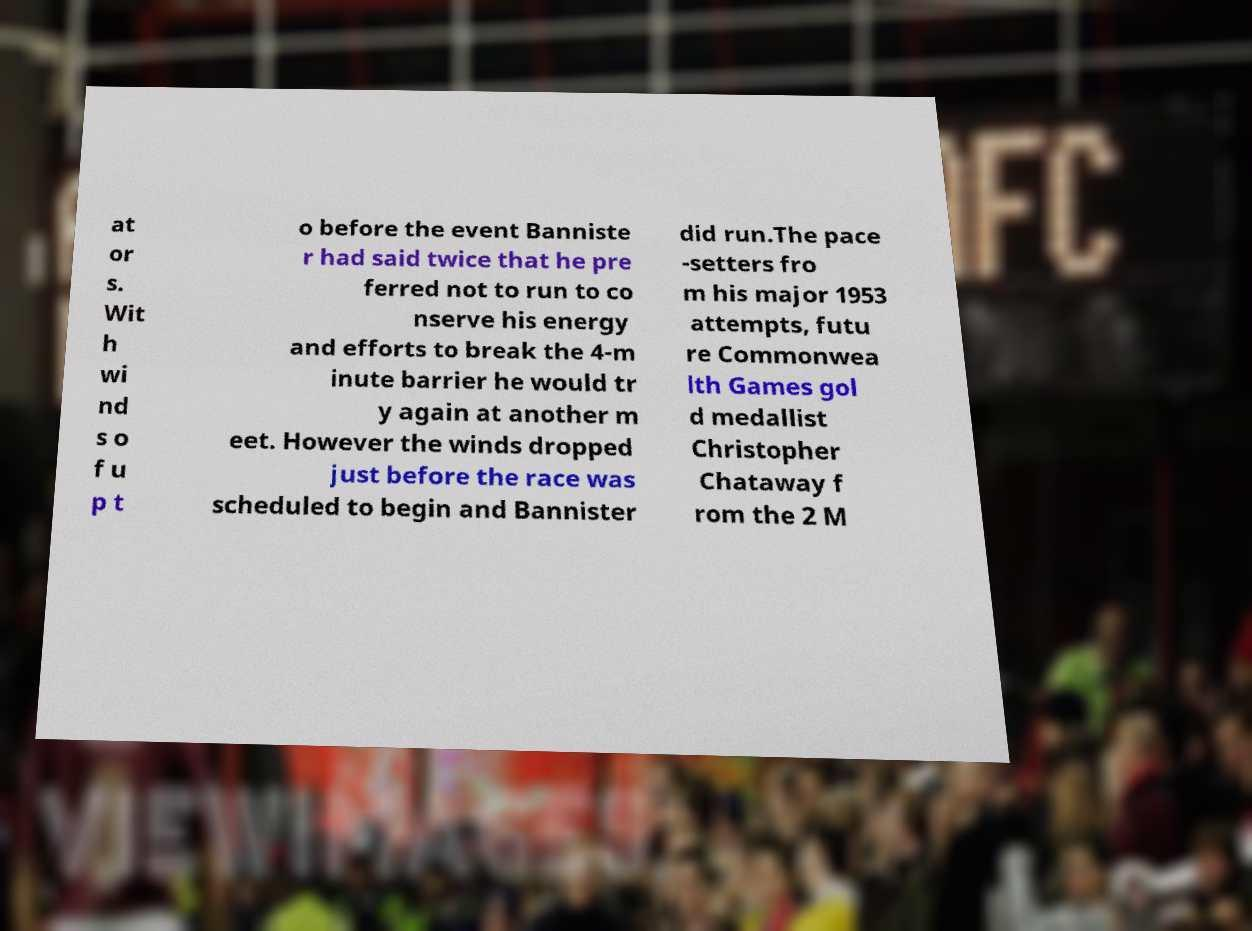For documentation purposes, I need the text within this image transcribed. Could you provide that? at or s. Wit h wi nd s o f u p t o before the event Banniste r had said twice that he pre ferred not to run to co nserve his energy and efforts to break the 4-m inute barrier he would tr y again at another m eet. However the winds dropped just before the race was scheduled to begin and Bannister did run.The pace -setters fro m his major 1953 attempts, futu re Commonwea lth Games gol d medallist Christopher Chataway f rom the 2 M 